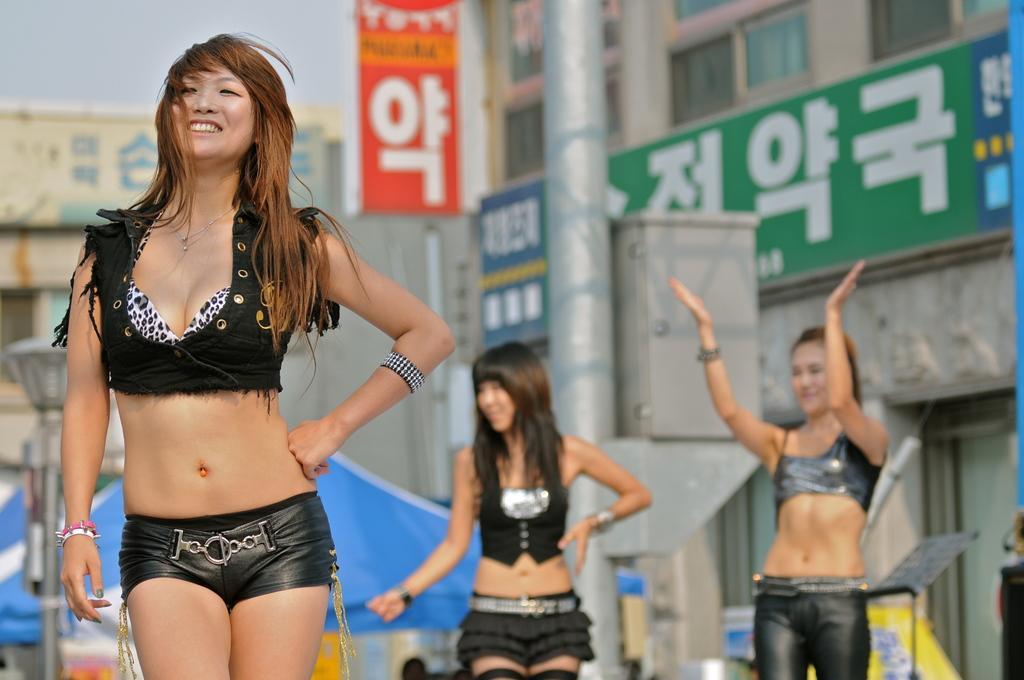Please provide a concise description of this image. In this image on the left side we can see a woman is standing and smiling. In the background we can see two women are standing, buildings, windows, tent, objects, rod, hoardings, light pole and sky. 